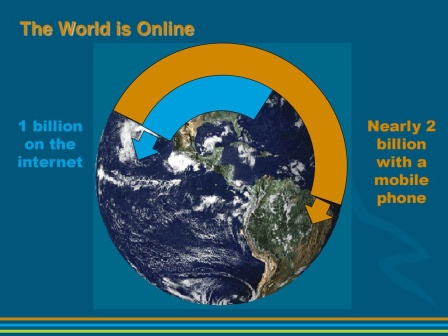What do you think is going on in this snapshot? The image vividly illustrates the pervasive reach of technology in the modern world. Highlighted by a schematic globe encircled by an orange arch, it emphasizes global connectivity. The arch starts with '1 billion on the internet' on one side, pointing to the spread of internet usage worldwide. On the opposite side, the phrase 'Nearly 2 billion with a mobile phone' represents mobile technology's extensive reach. Above, the bold headline 'The World is Online' underscores the digital era's omnipresence. This diagram likely aims to inform or persuade its viewers about the significant impact of technological advancements on global communication. 